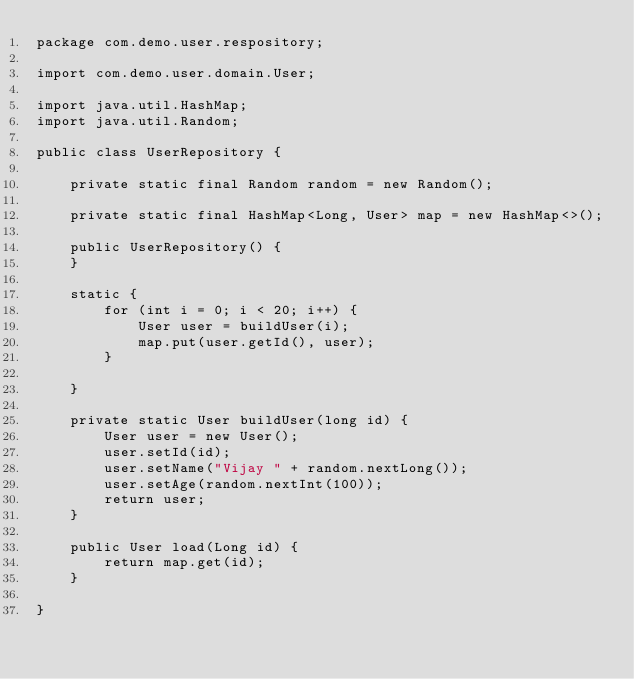<code> <loc_0><loc_0><loc_500><loc_500><_Java_>package com.demo.user.respository;

import com.demo.user.domain.User;

import java.util.HashMap;
import java.util.Random;

public class UserRepository {

    private static final Random random = new Random();

    private static final HashMap<Long, User> map = new HashMap<>();

    public UserRepository() {
    }

    static {
        for (int i = 0; i < 20; i++) {
            User user = buildUser(i);
            map.put(user.getId(), user);
        }

    }

    private static User buildUser(long id) {
        User user = new User();
        user.setId(id);
        user.setName("Vijay " + random.nextLong());
        user.setAge(random.nextInt(100));
        return user;
    }

    public User load(Long id) {
        return map.get(id);
    }

}
</code> 